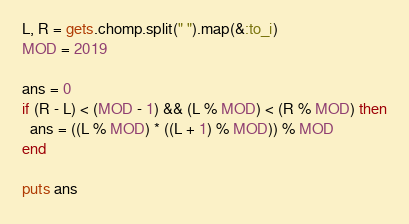<code> <loc_0><loc_0><loc_500><loc_500><_Ruby_>L, R = gets.chomp.split(" ").map(&:to_i)
MOD = 2019

ans = 0
if (R - L) < (MOD - 1) && (L % MOD) < (R % MOD) then
  ans = ((L % MOD) * ((L + 1) % MOD)) % MOD
end

puts ans
</code> 